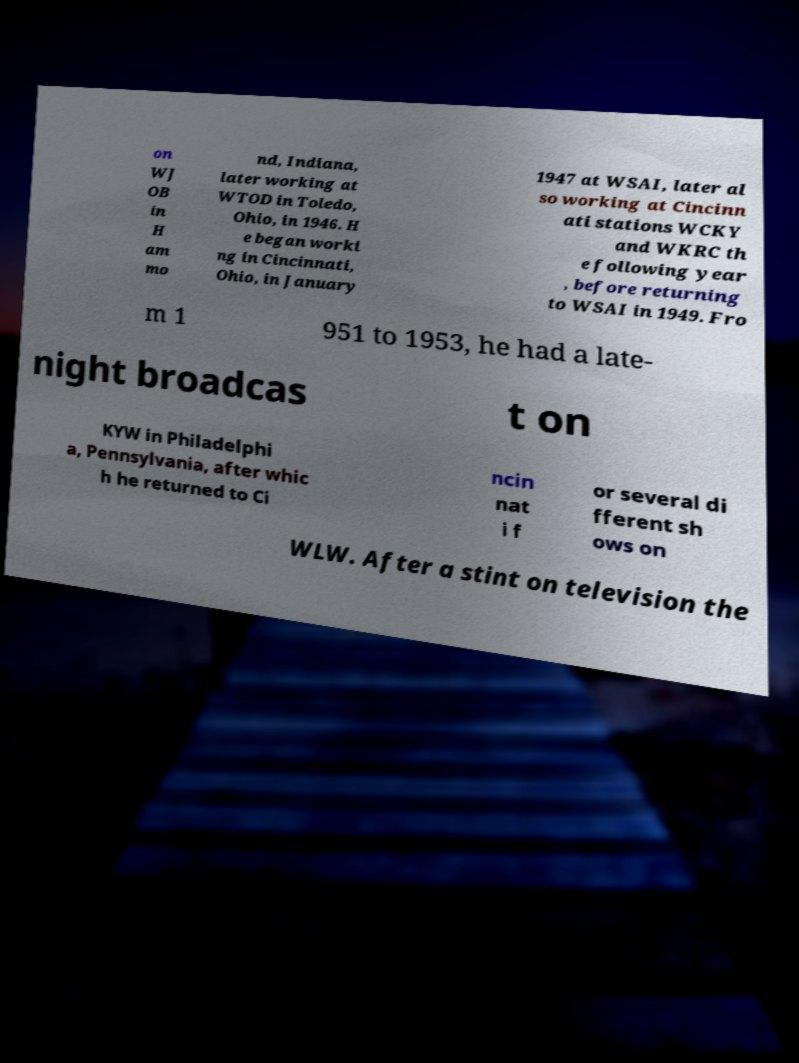Please identify and transcribe the text found in this image. on WJ OB in H am mo nd, Indiana, later working at WTOD in Toledo, Ohio, in 1946. H e began worki ng in Cincinnati, Ohio, in January 1947 at WSAI, later al so working at Cincinn ati stations WCKY and WKRC th e following year , before returning to WSAI in 1949. Fro m 1 951 to 1953, he had a late- night broadcas t on KYW in Philadelphi a, Pennsylvania, after whic h he returned to Ci ncin nat i f or several di fferent sh ows on WLW. After a stint on television the 